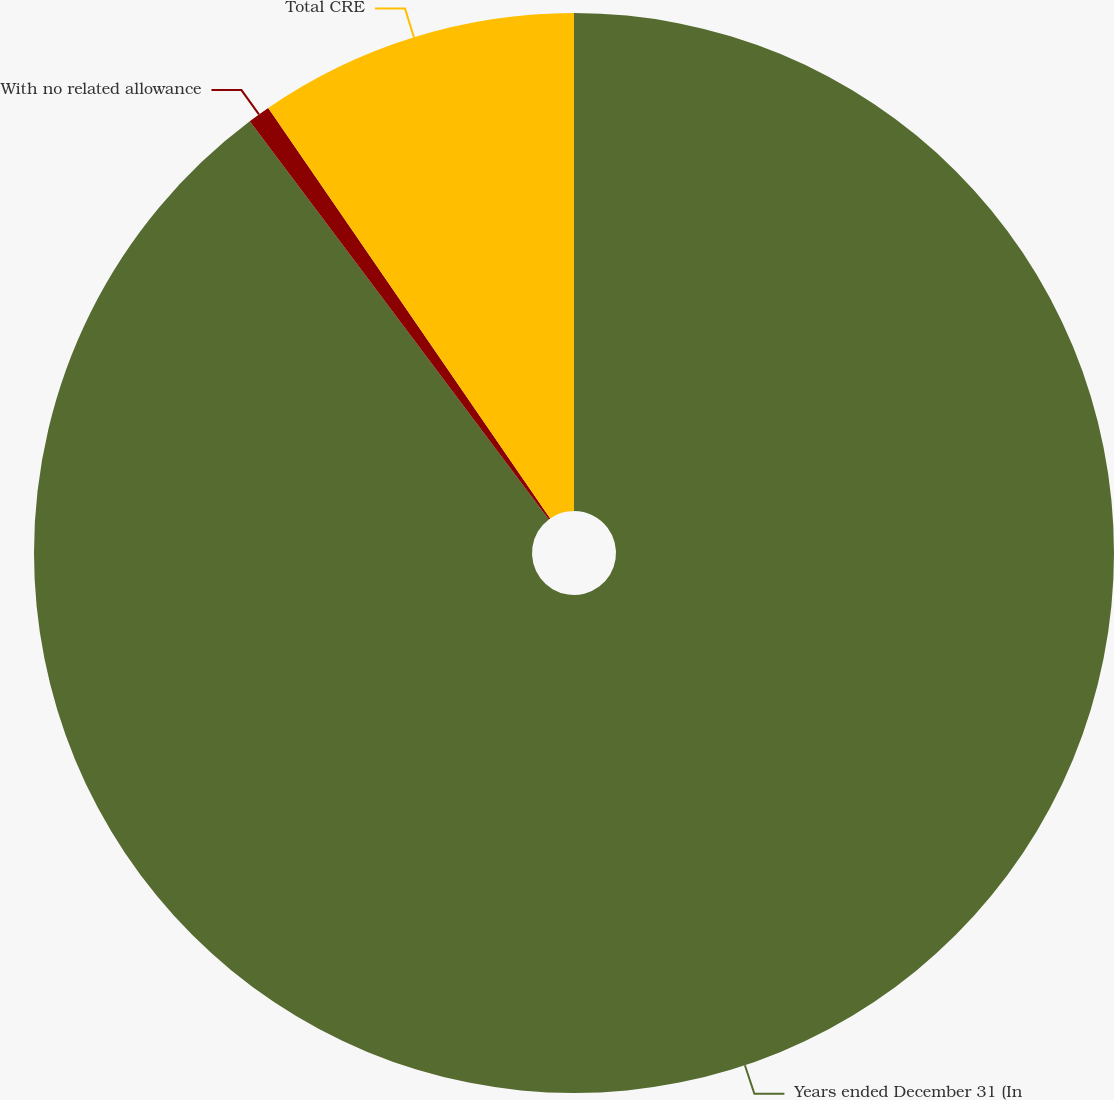<chart> <loc_0><loc_0><loc_500><loc_500><pie_chart><fcel>Years ended December 31 (In<fcel>With no related allowance<fcel>Total CRE<nl><fcel>89.75%<fcel>0.67%<fcel>9.58%<nl></chart> 